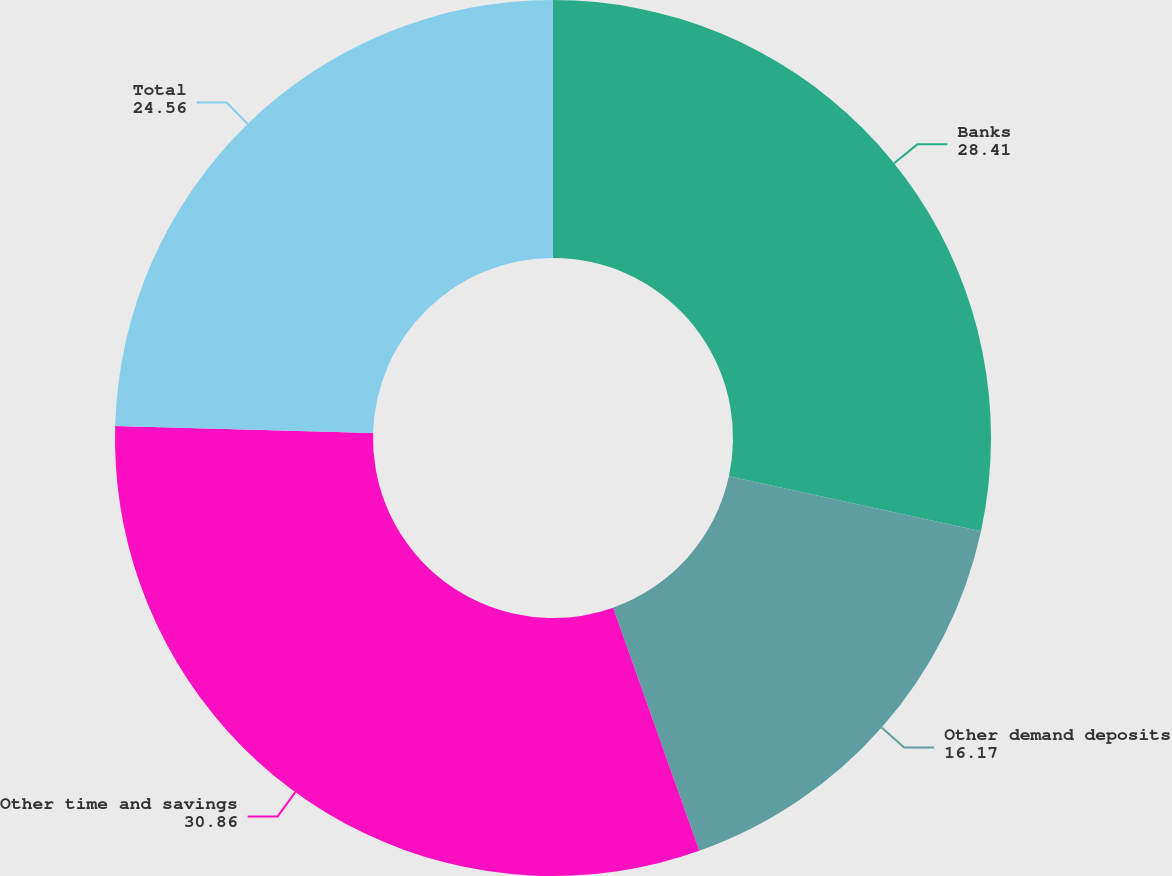<chart> <loc_0><loc_0><loc_500><loc_500><pie_chart><fcel>Banks<fcel>Other demand deposits<fcel>Other time and savings<fcel>Total<nl><fcel>28.41%<fcel>16.17%<fcel>30.86%<fcel>24.56%<nl></chart> 